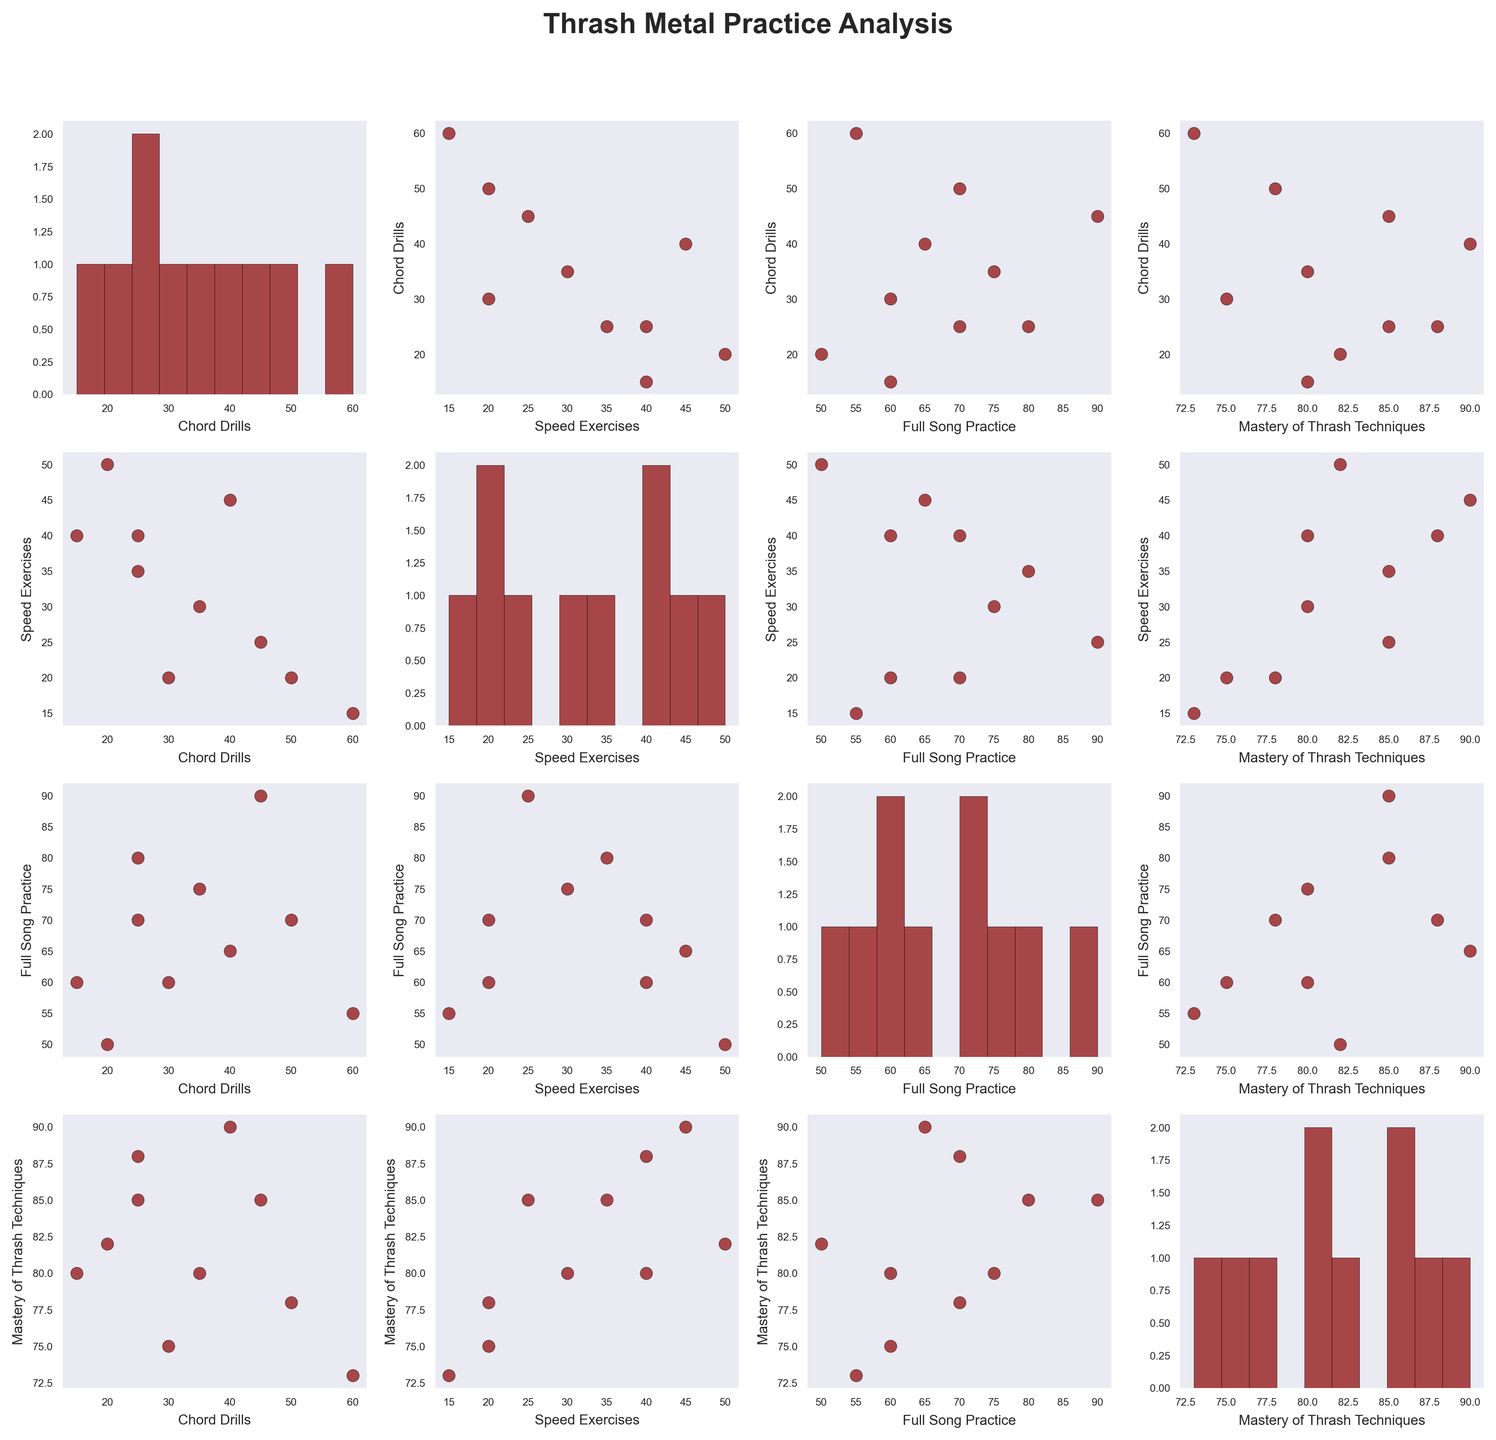How many data points are there in each scatter plot within the figure? Each scatter plot compares two variables from the dataset which consists of 10 practice sessions. Therefore, each scatter plot will have 10 data points.
Answer: 10 What does the diagonal of the plot matrix represent? The diagonal of the plot matrix represents the histogram of each variable (Chord Drills, Speed Exercises, Full Song Practice, and Mastery of Thrash Techniques). These show the frequency distribution of each variable.
Answer: Histograms Which practice session type seems to have the most spread in Mastery of Thrash Techniques? To find this, look at the scatter plots involving "Mastery of Thrash Techniques" as the y-axis. The "Speed Exercises" scatter plot shows points more spread out compared to "Chord Drills" and "Full Song Practice."
Answer: Speed Exercises Is there any noticeable positive or negative correlation between "Full Song Practice" and "Mastery of Thrash Techniques"? Check the scatter plot where "Full Song Practice" is on the x-axis and "Mastery of Thrash Techniques" is on the y-axis. There is a positive correlation visible since as the full song practice time increases, the mastery score seems to increase.
Answer: Positive What's the average duration of Speed Exercises across all sessions? Full Song Practice durations are: 20, 25, 40, 20, 35, 45, 30, 50, 15, 40. The sum of these durations is 320. Dividing by the number of sessions (10), the average is 320/10 = 32.
Answer: 32 Which practice session has the highest duration for Chord Drills, and what is the corresponding Mastery of Thrash Techniques score? By observing the scatter plots with "Chord Drills" on the x-axis, Session 9 has the highest duration for Chord Drills (60). The corresponding Mastery of Thrash Techniques score is 73.
Answer: Session 9, 73 Is there a stronger correlation between "Speed Exercises" and "Mastery of Thrash Techniques" or between "Chord Drills" and "Mastery of Thrash Techniques"? By observing scatter plots where "Mastery of Thrash Techniques" is on the y-axis, the correlation between "Speed Exercises" and "Mastery of Thrash Techniques" appears to be weaker compared to the correlation between "Chord Drills" and "Mastery of Thrash Techniques."
Answer: Chord Drills Which variables show no visible correlation when plotted against each other? Check scatter plots for combinations of variables where the points do not display any clear pattern (positive or negative). The scatter plot of "Chord Drills" vs. "Speed Exercises" shows no visible correlation.
Answer: Chord Drills and Speed Exercises What's the highest recorded Mastery of Thrash Techniques, and which session achieved it? By checking the histograms and scatter plots for "Mastery of Thrash Techniques," the highest recorded score is 90 during Session 6.
Answer: 90, Session 6 